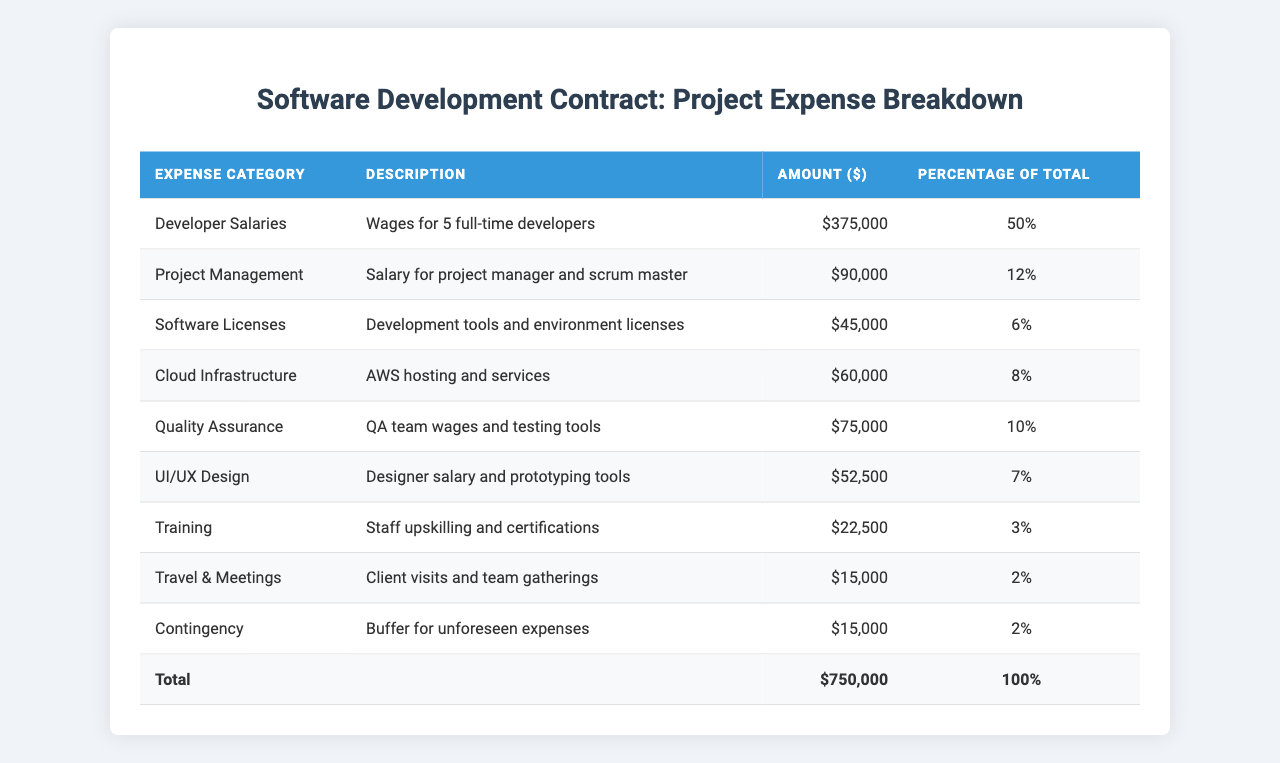What is the total amount spent on Developer Salaries? The table shows that the amount for Developer Salaries is listed as $375,000.
Answer: $375,000 What percentage of the total expenses is allocated to Project Management? According to the table, Project Management is allocated 12% of the total expenses.
Answer: 12% How much more is spent on Developer Salaries compared to Training? The amount for Developer Salaries is $375,000, and for Training, it is $22,500. The difference is $375,000 - $22,500 = $352,500.
Answer: $352,500 Is the amount spent on Quality Assurance more than the amount spent on Travel & Meetings? Quality Assurance is $75,000 and Travel & Meetings is $15,000. Since $75,000 is greater than $15,000, the statement is true.
Answer: Yes What is the total amount spent on Software Licenses and Cloud Infrastructure combined? The amount spent on Software Licenses is $45,000 and on Cloud Infrastructure is $60,000. Adding them together gives $45,000 + $60,000 = $105,000.
Answer: $105,000 What is the average percentage allocated to the various expense categories? There are 9 categories, and their total percentage is 100%. The average is 100% / 9 = approximately 11.11%.
Answer: 11.11% How much is allocated for contingency compared to the total spent on UI/UX Design? Contingency has an allocation of $15,000, while UI/UX Design has $52,500. Since $15,000 is less than $52,500, the budget is lower for contingency.
Answer: Yes What percentage of the total expenses is spent on Quality Assurance and Training combined? Quality Assurance is 10% and Training is 3%. Adding these values gives 10% + 3% = 13% of the total expenses combined.
Answer: 13% Which expense category has the lowest monetary value, and what is that amount? The expense category with the lowest amount is Travel & Meetings at $15,000, as all other entries have higher amounts.
Answer: $15,000 If the total project expenses are $750,000, what would be the budget for Cloud Infrastructure based on its percentage? The percentage for Cloud Infrastructure is 8%. Therefore, the budget would be calculated as 8% of $750,000, which is $750,000 x 0.08 = $60,000.
Answer: $60,000 